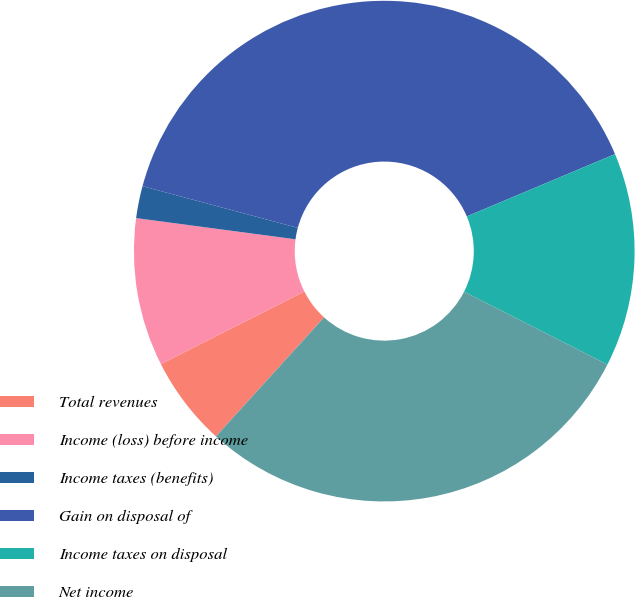Convert chart to OTSL. <chart><loc_0><loc_0><loc_500><loc_500><pie_chart><fcel>Total revenues<fcel>Income (loss) before income<fcel>Income taxes (benefits)<fcel>Gain on disposal of<fcel>Income taxes on disposal<fcel>Net income<nl><fcel>5.81%<fcel>9.56%<fcel>2.07%<fcel>39.49%<fcel>13.82%<fcel>29.25%<nl></chart> 